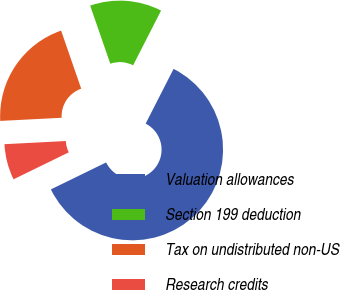<chart> <loc_0><loc_0><loc_500><loc_500><pie_chart><fcel>Valuation allowances<fcel>Section 199 deduction<fcel>Tax on undistributed non-US<fcel>Research credits<nl><fcel>60.26%<fcel>12.82%<fcel>20.51%<fcel>6.41%<nl></chart> 